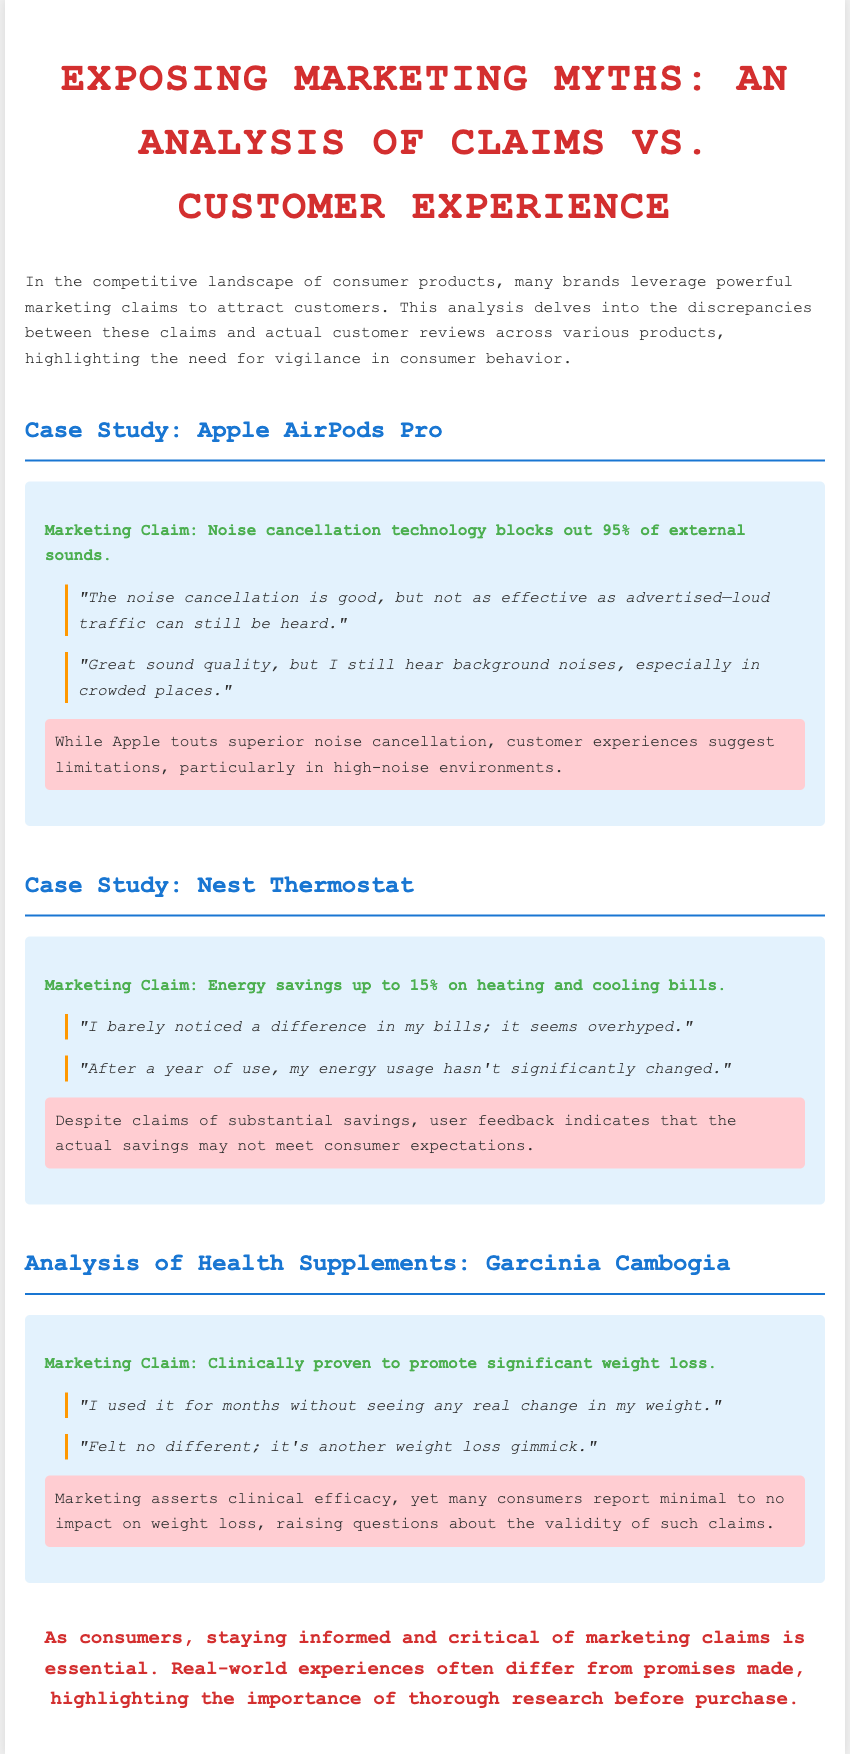What is the marketing claim for Apple AirPods Pro? The marketing claim states that the noise cancellation technology blocks out 95% of external sounds.
Answer: Noise cancellation technology blocks out 95% of external sounds What do customers say about the noise cancellation of AirPods Pro? Customers express that while the noise cancellation is good, it is not as effective as advertised, with background noises still heard.
Answer: Not as effective as advertised What is the marketing claim regarding Nest Thermostat energy savings? The claim suggests energy savings up to 15% on heating and cooling bills.
Answer: Energy savings up to 15% How do customers feel about the weight loss claims of Garcinia Cambogia? Customers report that they used the supplement for months without seeing any real change in weight, questioning its effectiveness.
Answer: Minimal to no impact on weight loss What is the primary conclusion of the document? The conclusion emphasizes the importance of being informed and critical of marketing claims, as real-world experiences often differ from promises made.
Answer: Staying informed and critical of marketing claims is essential What is indicated by the discrepancy summary for Nest Thermostat? The discrepancy summary indicates that user feedback highlights that actual energy savings may not meet consumer expectations.
Answer: Actual savings may not meet consumer expectations What color is used for the heading of the case studies? The case study headings are styled with a blue color.
Answer: Blue How many customer reviews are presented for Garcinia Cambogia? There are two customer reviews presented that discuss Garcinia Cambogia.
Answer: Two 